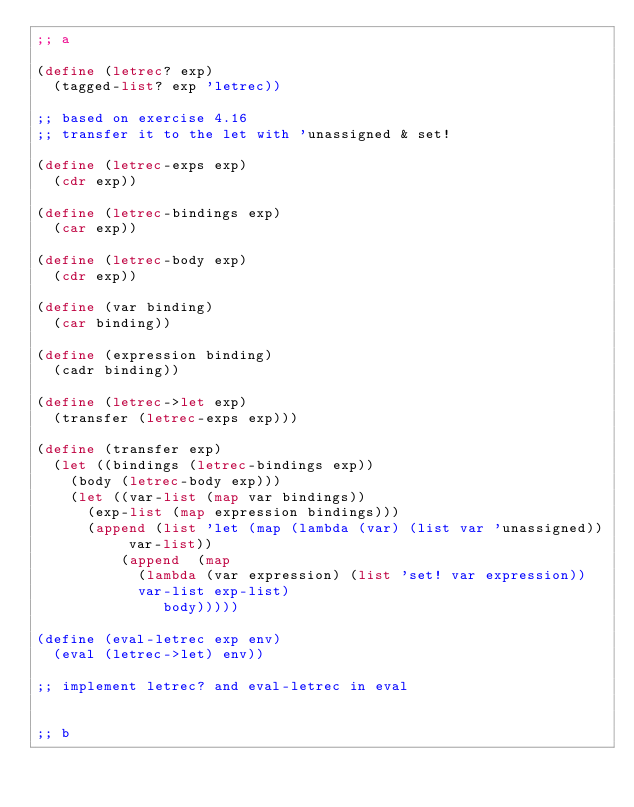Convert code to text. <code><loc_0><loc_0><loc_500><loc_500><_Scheme_>;; a

(define (letrec? exp)
  (tagged-list? exp 'letrec))

;; based on exercise 4.16
;; transfer it to the let with 'unassigned & set!

(define (letrec-exps exp)
  (cdr exp))

(define (letrec-bindings exp)
  (car exp))

(define (letrec-body exp)
  (cdr exp))

(define (var binding)
  (car binding))

(define (expression binding)
  (cadr binding))

(define (letrec->let exp)
  (transfer (letrec-exps exp)))

(define (transfer exp)
  (let ((bindings (letrec-bindings exp))
	(body (letrec-body exp)))
    (let ((var-list (map var bindings))
	  (exp-list (map expression bindings)))
      (append (list 'let (map (lambda (var) (list var 'unassigned)) var-list))
	      (append  (map
			(lambda (var expression) (list 'set! var expression))
			var-list exp-list)
		       body)))))

(define (eval-letrec exp env)
  (eval (letrec->let) env))

;; implement letrec? and eval-letrec in eval


;; b
</code> 